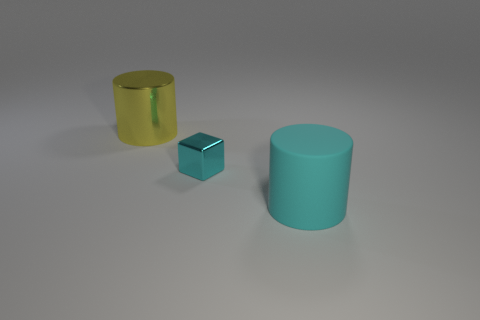How many things are either big cylinders behind the big cyan thing or yellow things?
Keep it short and to the point. 1. Are any big rubber cylinders visible?
Make the answer very short. Yes. There is a big object that is in front of the yellow shiny object; what material is it?
Your answer should be compact. Rubber. What material is the cylinder that is the same color as the tiny thing?
Provide a short and direct response. Rubber. How many tiny things are either green matte cubes or cylinders?
Your response must be concise. 0. What color is the small thing?
Make the answer very short. Cyan. Is there a cyan rubber cylinder behind the metal thing to the right of the large metal cylinder?
Ensure brevity in your answer.  No. Are there fewer big cylinders left of the large yellow object than large metallic cylinders?
Provide a short and direct response. Yes. Does the large object to the right of the large yellow shiny cylinder have the same material as the small cyan thing?
Offer a very short reply. No. What is the color of the other thing that is the same material as the small cyan thing?
Your answer should be compact. Yellow. 